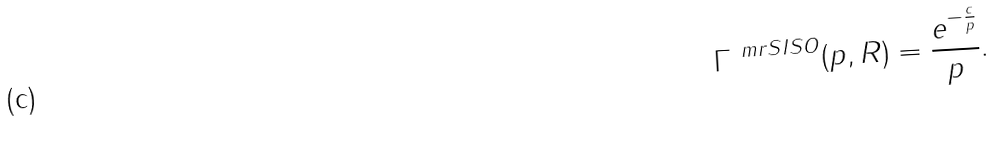<formula> <loc_0><loc_0><loc_500><loc_500>\Gamma ^ { \ m r { S I S O } } ( p , R ) = \frac { e ^ { - \frac { c } { p } } } { p } .</formula> 